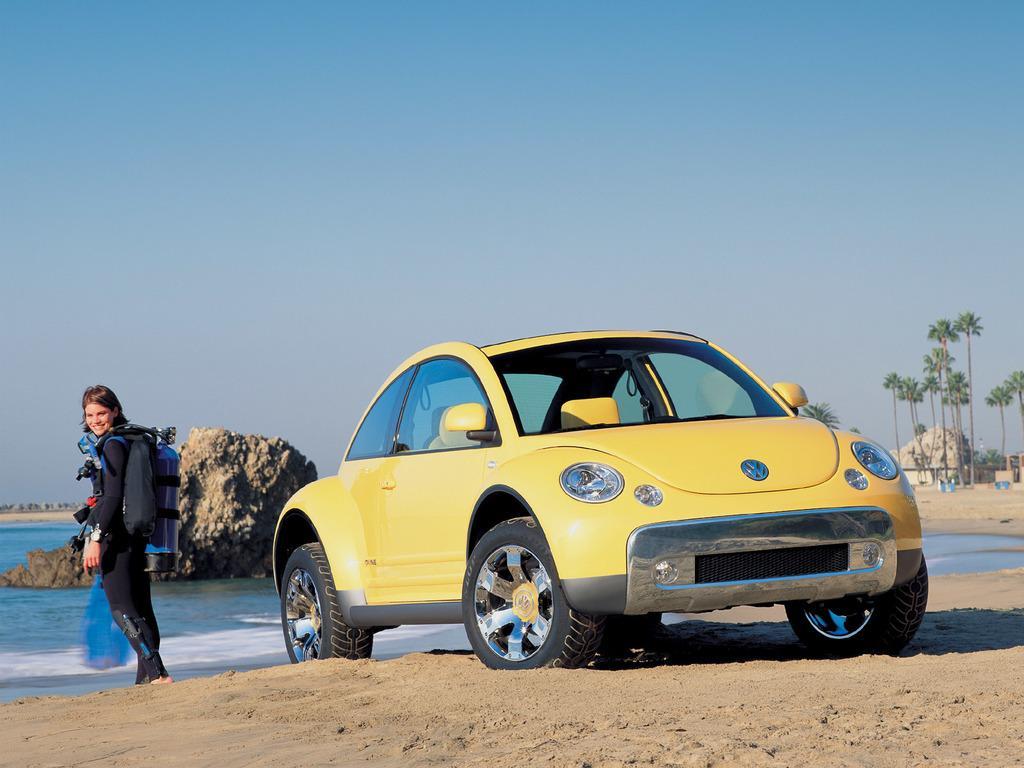Describe this image in one or two sentences. At the bottom of the image on the sea shore there is a car. And also there is a lady standing and carrying an oxygen cylinder on her back. Behind her there is a rock in the water. On the right side of the image in the background there are trees. At the top of the image there is sky. 